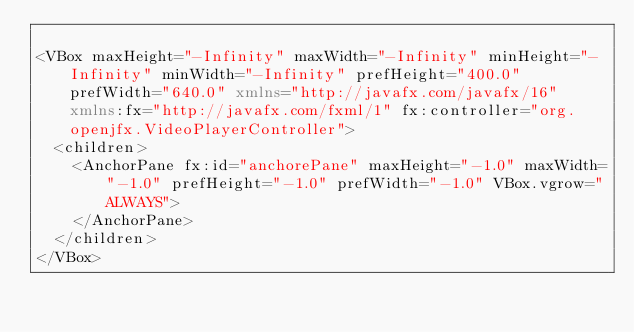Convert code to text. <code><loc_0><loc_0><loc_500><loc_500><_XML_>
<VBox maxHeight="-Infinity" maxWidth="-Infinity" minHeight="-Infinity" minWidth="-Infinity" prefHeight="400.0" prefWidth="640.0" xmlns="http://javafx.com/javafx/16" xmlns:fx="http://javafx.com/fxml/1" fx:controller="org.openjfx.VideoPlayerController">
  <children>
    <AnchorPane fx:id="anchorePane" maxHeight="-1.0" maxWidth="-1.0" prefHeight="-1.0" prefWidth="-1.0" VBox.vgrow="ALWAYS">
    </AnchorPane>
  </children>
</VBox>
</code> 